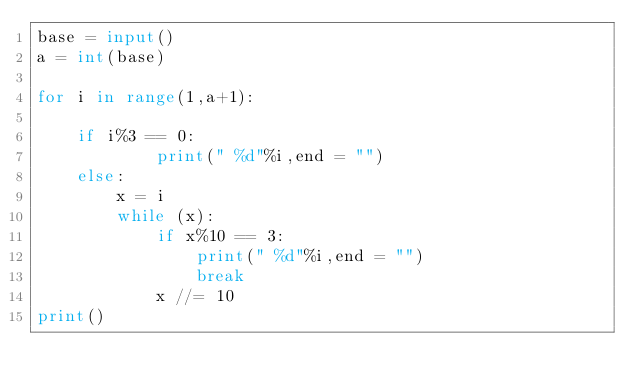Convert code to text. <code><loc_0><loc_0><loc_500><loc_500><_Python_>base = input()
a = int(base)

for i in range(1,a+1):

    if i%3 == 0:
            print(" %d"%i,end = "")
    else:
        x = i
        while (x):
            if x%10 == 3:
                print(" %d"%i,end = "")
                break
            x //= 10
print()

</code> 